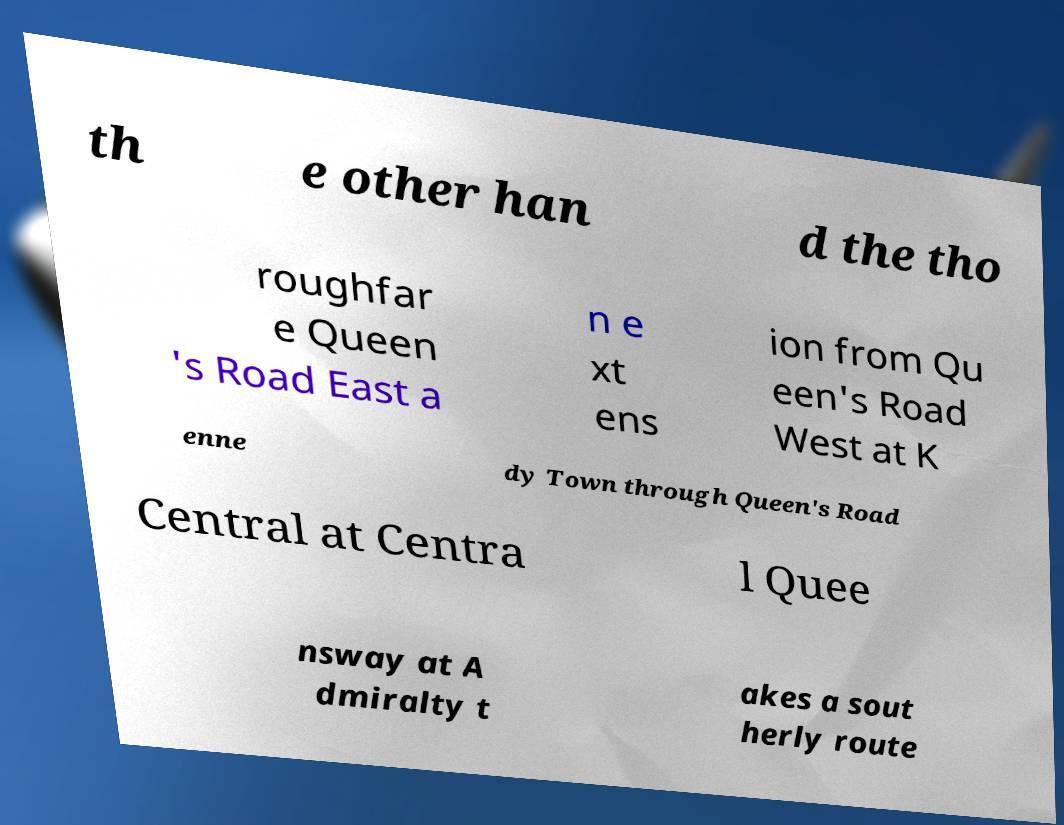Could you extract and type out the text from this image? th e other han d the tho roughfar e Queen 's Road East a n e xt ens ion from Qu een's Road West at K enne dy Town through Queen's Road Central at Centra l Quee nsway at A dmiralty t akes a sout herly route 